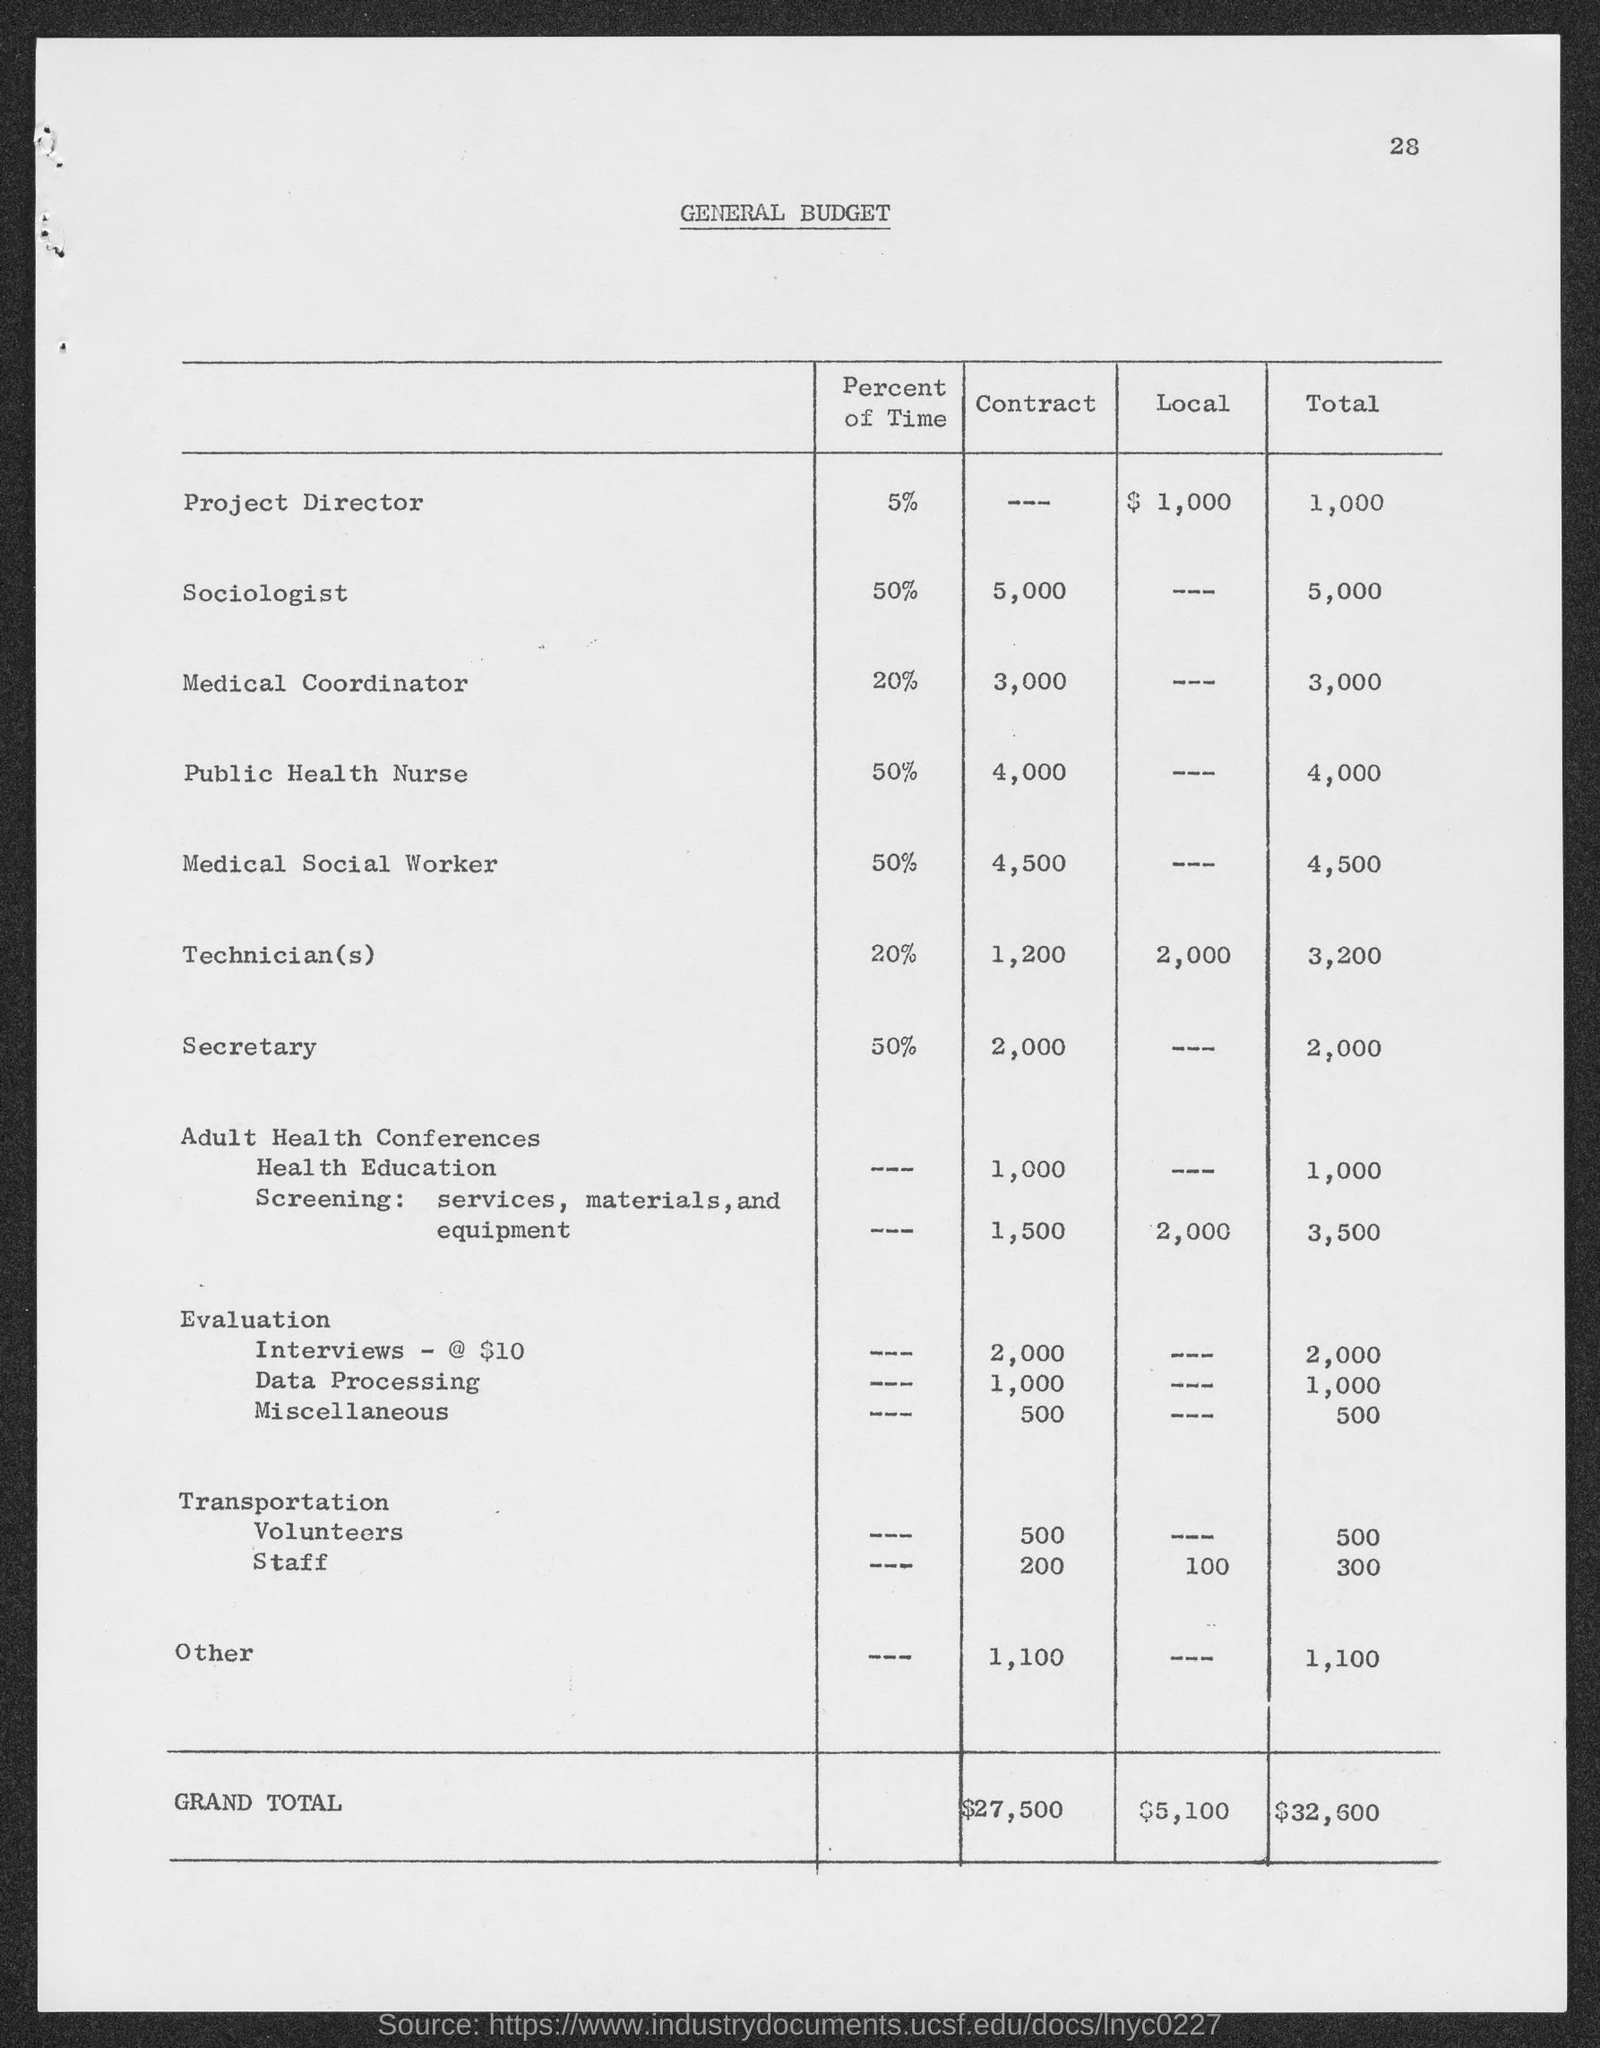What is the title of the table?
Offer a very short reply. General Budget. What is the page number at top of the page?
Ensure brevity in your answer.  28. What is the general budget total  for project director ?
Ensure brevity in your answer.  1,000. What is the general budget total  for sociologist ?
Offer a terse response. $5,000. What is the general budget total for medical coordinator?
Your response must be concise. $3,000. What is the general budget total  for public health nurse?
Your response must be concise. 4,000. What is the general budget total for medical social worker ?
Your answer should be compact. 4,500. What is the general budget total for technician(s)  ?
Provide a succinct answer. 3,200. What is the general budget total for secretary ?
Your response must be concise. 2,000. What is the general budget grand total ?
Give a very brief answer. $32,600. 